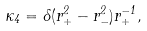Convert formula to latex. <formula><loc_0><loc_0><loc_500><loc_500>\kappa _ { 4 } = \Lambda ( r _ { + } ^ { 2 } - r _ { - } ^ { 2 } ) r _ { + } ^ { - 1 } ,</formula> 